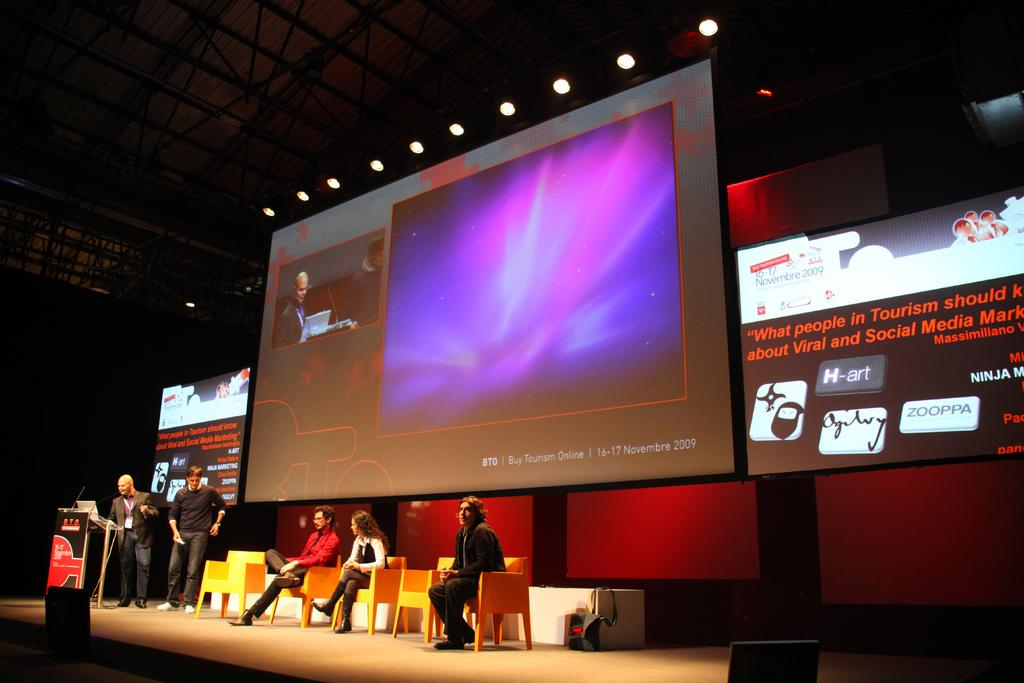<image>
Give a short and clear explanation of the subsequent image. People are giving a presentation on stage about tourism. 